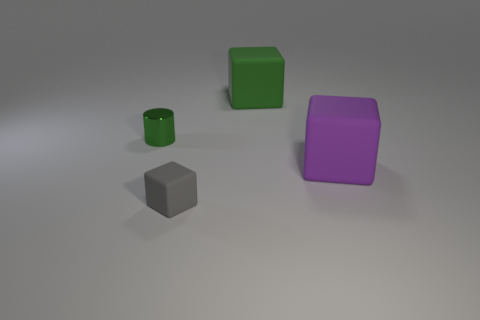Subtract all big matte blocks. How many blocks are left? 1 Add 3 green cubes. How many objects exist? 7 Subtract all cylinders. How many objects are left? 3 Subtract all blue cubes. Subtract all brown balls. How many cubes are left? 3 Add 3 big matte objects. How many big matte objects are left? 5 Add 3 big green objects. How many big green objects exist? 4 Subtract 0 cyan cylinders. How many objects are left? 4 Subtract all small gray cubes. Subtract all small gray objects. How many objects are left? 2 